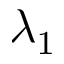Convert formula to latex. <formula><loc_0><loc_0><loc_500><loc_500>\lambda _ { 1 }</formula> 